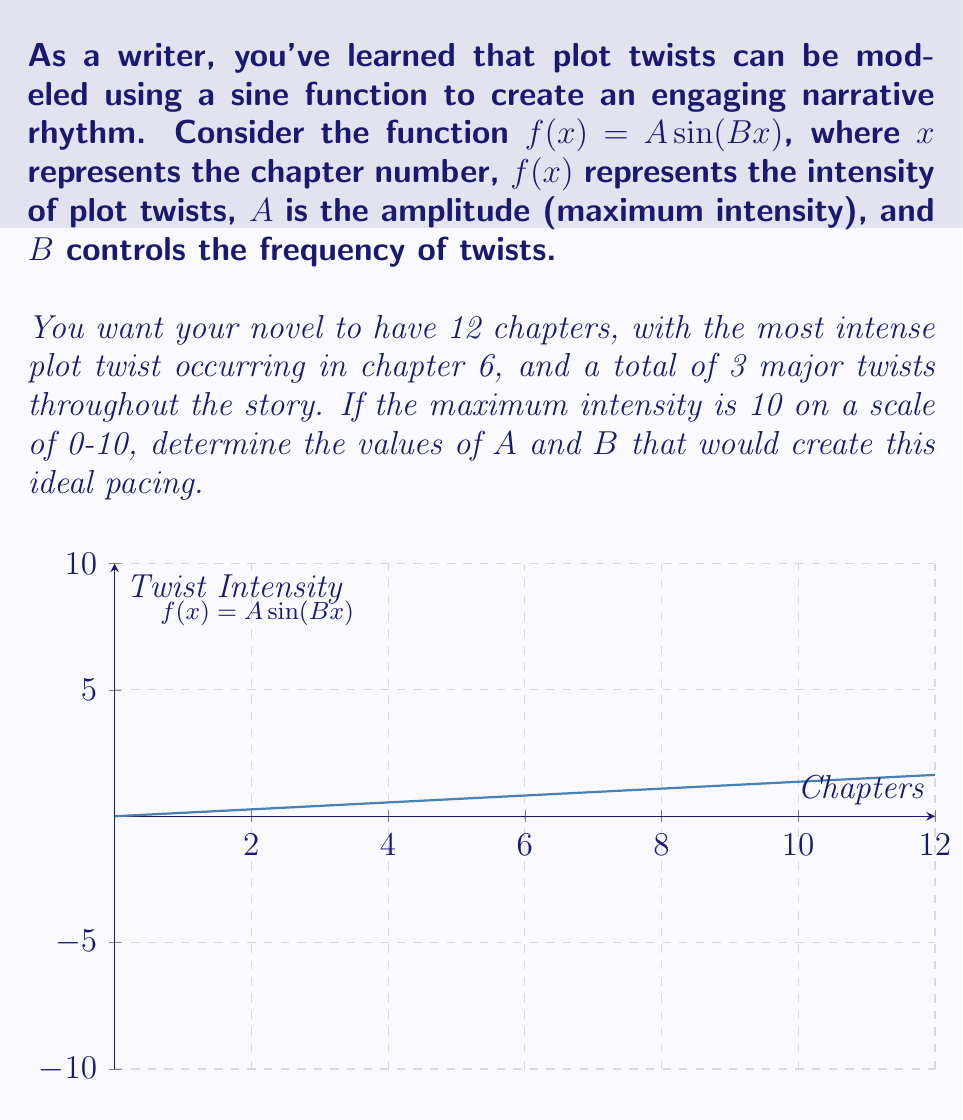Solve this math problem. Let's approach this step-by-step:

1) We know that the function is of the form $f(x) = A \sin(Bx)$.

2) The amplitude $A$ is half of the range. Since the intensity goes from 0 to 10, $A = 5$.

3) For the period, we need 3 major twists in 12 chapters. This means one complete cycle occurs every 4 chapters. The period of a sine function is given by $\frac{2\pi}{B}$. So:

   $\frac{2\pi}{B} = 4$

4) Solving for $B$:
   $B = \frac{2\pi}{4} = \frac{\pi}{2}$

5) To verify, let's check if the most intense twist occurs at chapter 6:
   $f(6) = 5 \sin(\frac{\pi}{2} \cdot 6) = 5 \sin(3\pi) = 0$

   This is correct because $\sin(3\pi)$ is at its maximum value of 1.

6) Therefore, our final function is:

   $f(x) = 5 \sin(\frac{\pi}{2}x)$

This function will create 3 major twists over 12 chapters, with the most intense twist at chapter 6.
Answer: $A = 5$, $B = \frac{\pi}{2}$ 